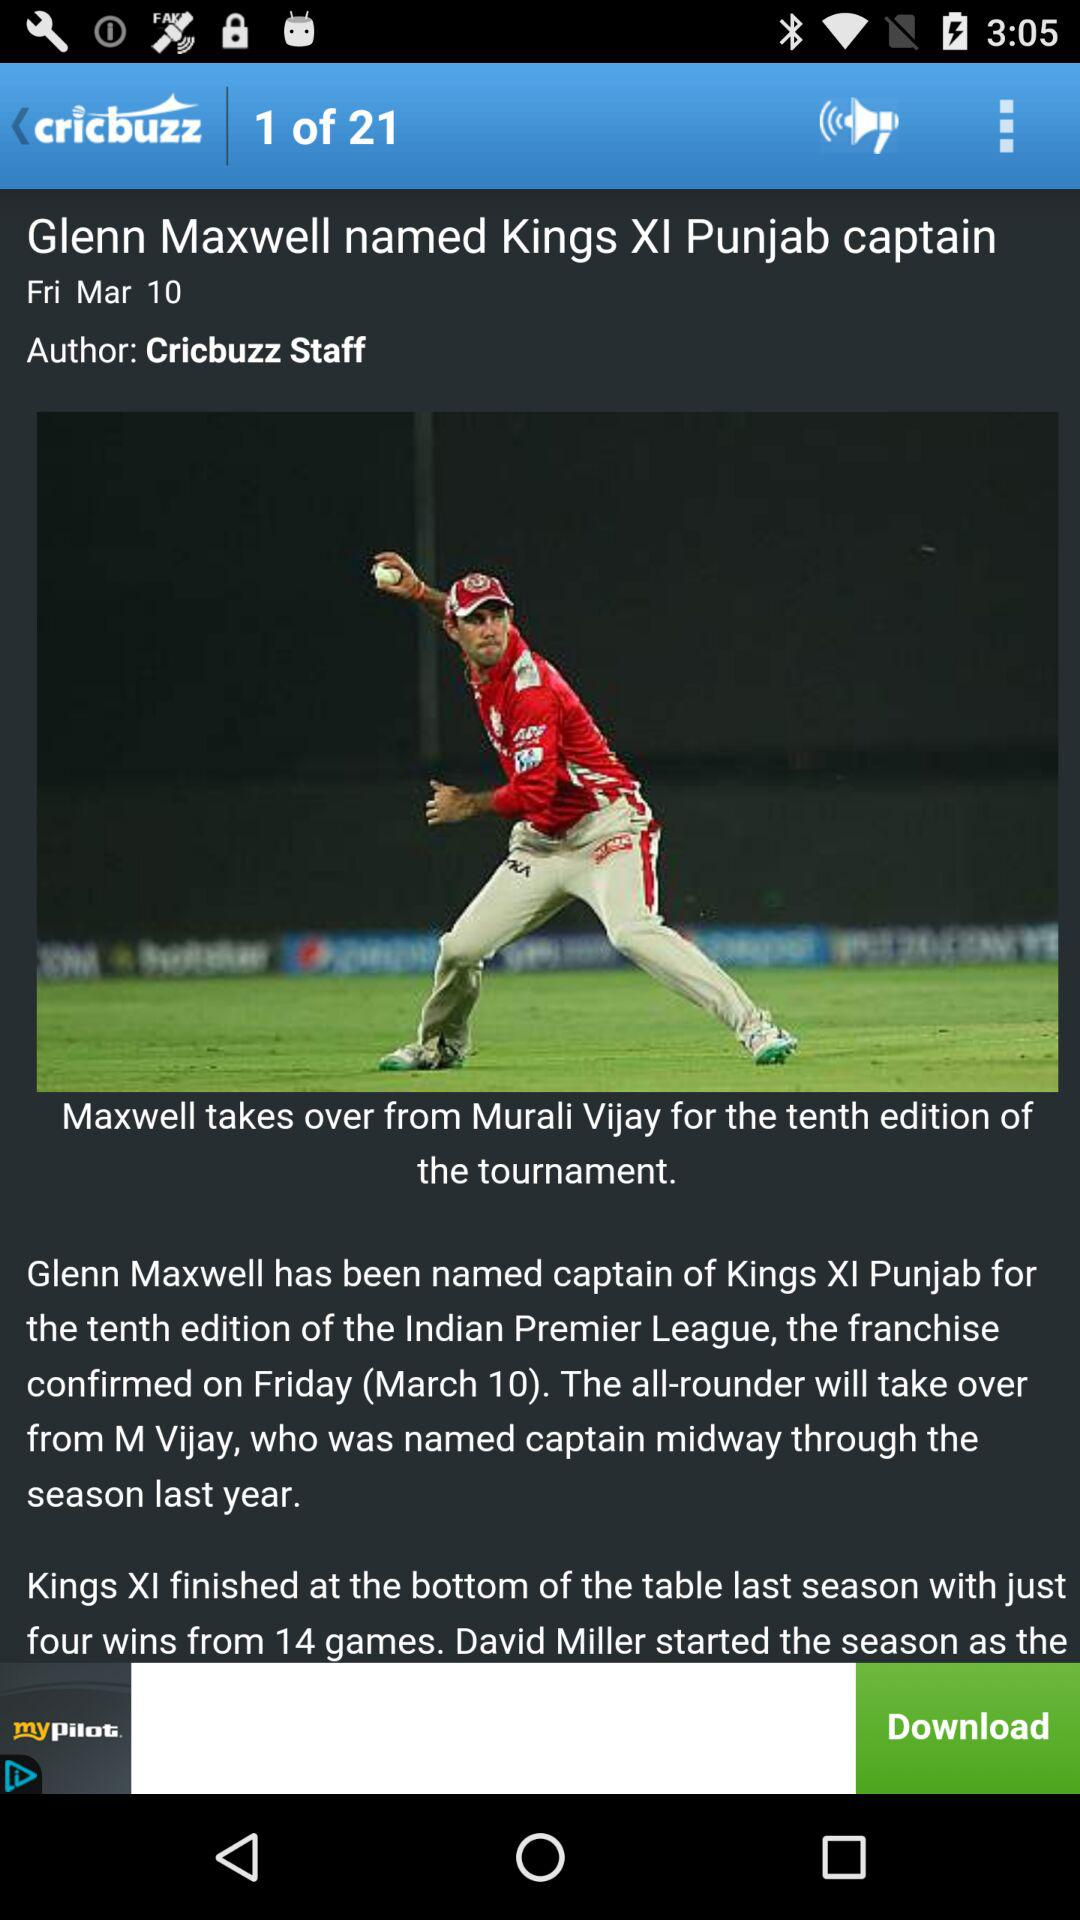How many total pages are there? There are a total of 21 pages. 